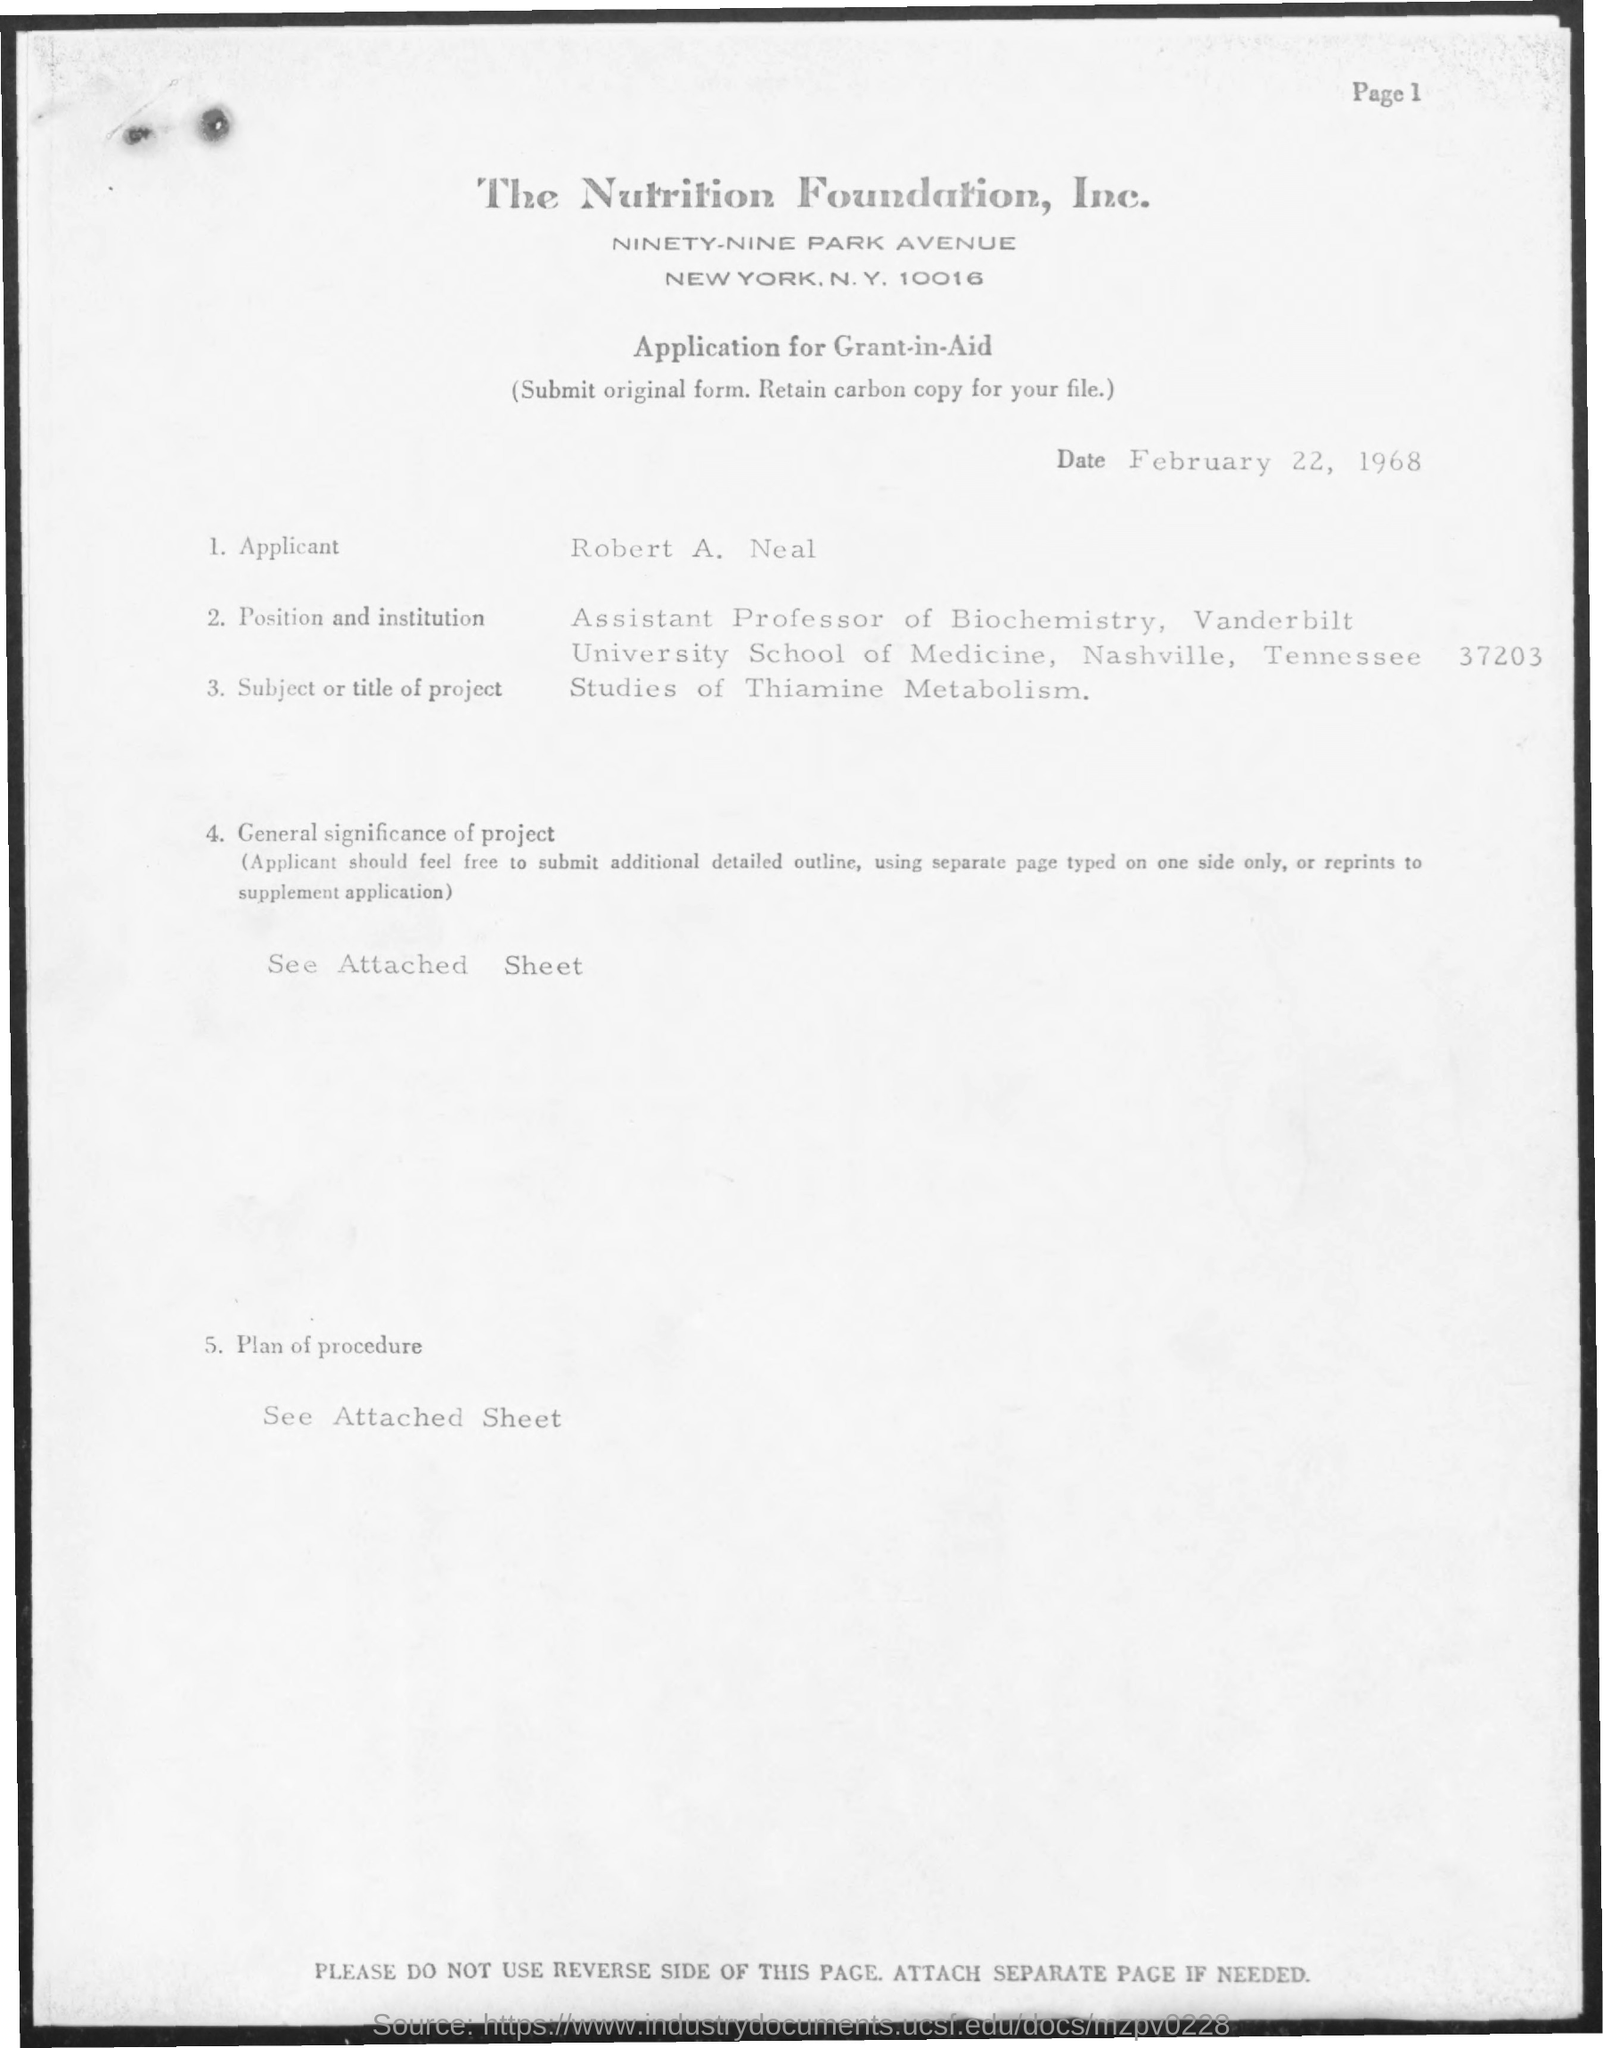Indicate a few pertinent items in this graphic. The application is for a grant-in-aid. The Nutrition Foundation, Inc. is the name of the foundation. The project is called 'Studies of Thiamine Metabolism.' The date of application is February 22, 1968. I am an Assistant Professor of Biochemistry. 